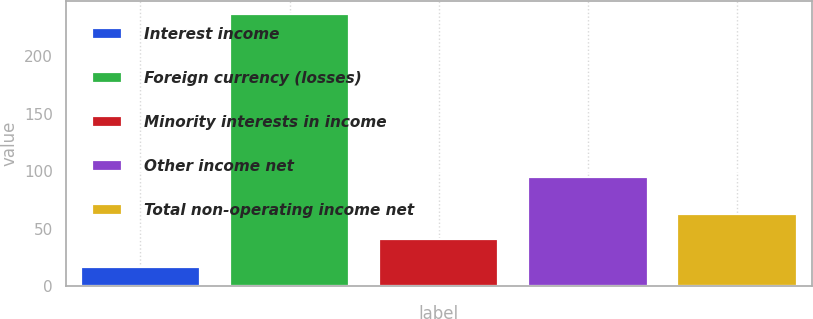Convert chart. <chart><loc_0><loc_0><loc_500><loc_500><bar_chart><fcel>Interest income<fcel>Foreign currency (losses)<fcel>Minority interests in income<fcel>Other income net<fcel>Total non-operating income net<nl><fcel>17<fcel>236<fcel>41<fcel>95<fcel>63<nl></chart> 